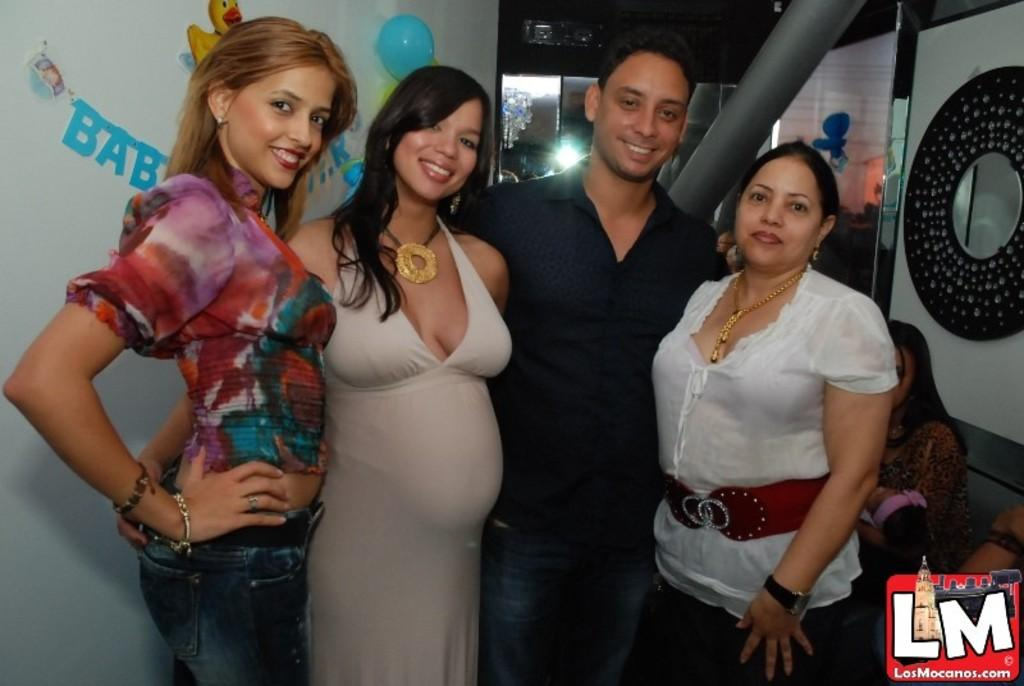How many people are in the image? There are four persons in the image. What can be seen on the wall behind the persons? There are decorations on the wall behind the persons. What are the people in the image doing? There are people sitting in the image. What architectural features can be seen in the image? There is a door and a pole in the image. What type of muscle is visible on the person's leg in the image? There is no muscle or leg visible in the image; the image only shows people sitting and the surrounding environment. 